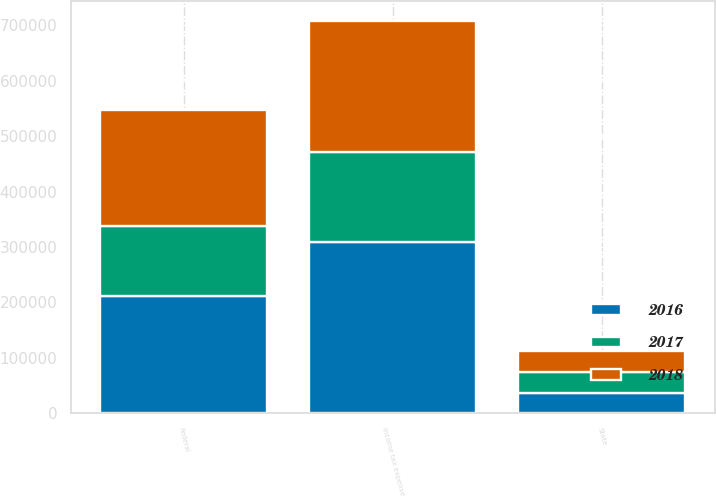<chart> <loc_0><loc_0><loc_500><loc_500><stacked_bar_chart><ecel><fcel>Federal<fcel>State<fcel>Income tax expense<nl><fcel>2017<fcel>126358<fcel>37038<fcel>162535<nl><fcel>2016<fcel>211641<fcel>37006<fcel>309390<nl><fcel>2018<fcel>209454<fcel>38095<fcel>236435<nl></chart> 